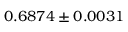<formula> <loc_0><loc_0><loc_500><loc_500>0 . 6 8 7 4 \pm 0 . 0 0 3 1</formula> 